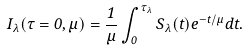Convert formula to latex. <formula><loc_0><loc_0><loc_500><loc_500>I _ { \lambda } ( \tau = 0 , \mu ) = \frac { 1 } { \mu } \int _ { 0 } ^ { \tau _ { \lambda } } S _ { \lambda } ( t ) e ^ { - t / \mu } d t .</formula> 